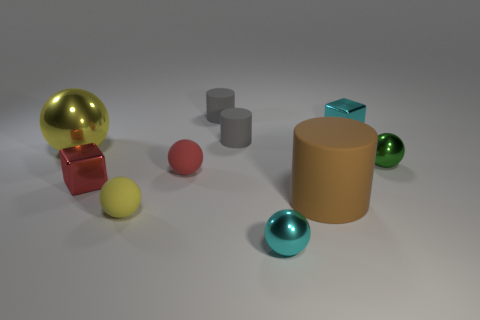What size is the sphere that is both left of the big rubber cylinder and behind the red rubber sphere?
Make the answer very short. Large. What number of other objects are the same shape as the big brown matte object?
Make the answer very short. 2. How many other objects are there of the same material as the tiny red sphere?
Your answer should be very brief. 4. What size is the yellow metal thing that is the same shape as the small yellow rubber thing?
Make the answer very short. Large. There is a tiny thing that is both behind the large yellow object and right of the brown rubber object; what is its color?
Provide a short and direct response. Cyan. What number of things are tiny shiny things that are behind the brown thing or yellow metallic balls?
Your answer should be very brief. 4. There is another big metallic thing that is the same shape as the green object; what is its color?
Keep it short and to the point. Yellow. There is a green object; is it the same shape as the cyan thing that is in front of the yellow matte object?
Provide a short and direct response. Yes. What number of things are tiny metallic balls that are in front of the tiny yellow matte sphere or cyan things that are on the left side of the large brown thing?
Offer a very short reply. 1. Is the number of cyan shiny things that are behind the tiny green sphere less than the number of small gray cylinders?
Make the answer very short. Yes. 